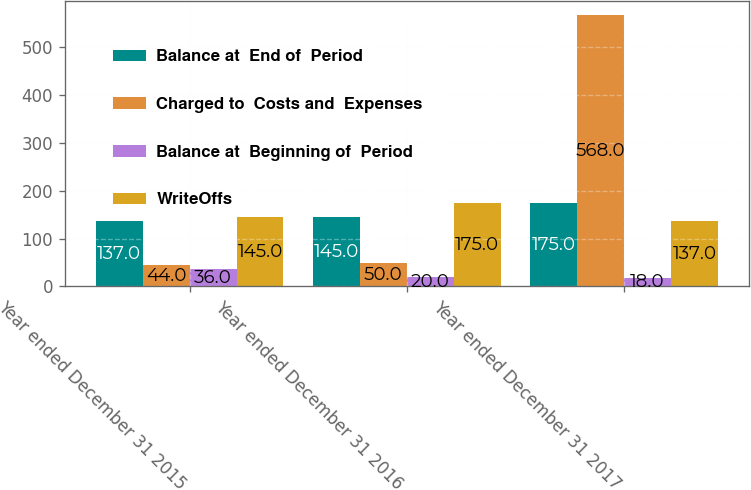<chart> <loc_0><loc_0><loc_500><loc_500><stacked_bar_chart><ecel><fcel>Year ended December 31 2015<fcel>Year ended December 31 2016<fcel>Year ended December 31 2017<nl><fcel>Balance at  End of  Period<fcel>137<fcel>145<fcel>175<nl><fcel>Charged to  Costs and  Expenses<fcel>44<fcel>50<fcel>568<nl><fcel>Balance at  Beginning of  Period<fcel>36<fcel>20<fcel>18<nl><fcel>WriteOffs<fcel>145<fcel>175<fcel>137<nl></chart> 